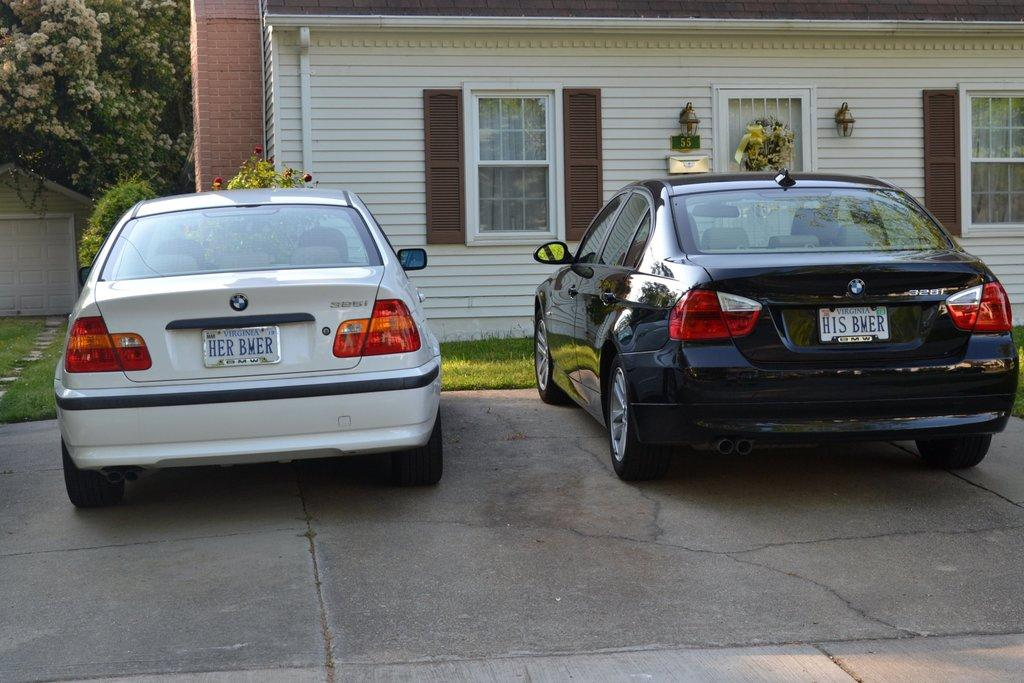<image>
Give a short and clear explanation of the subsequent image. The white BMW car on the left has an unusual registration saying HER BMER. 